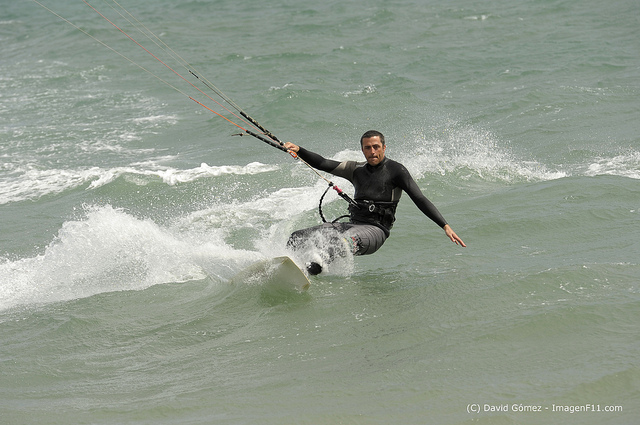<image>What sport is this? It is ambiguous which sport this is. The possibilities could include water skiing, windsurfing, parasailing, water kiting, kitesurfing, or parasurfing. What sport is this? I don't know what sport this is. It can be water skiing, windsurfing, parasailing, water kiting, kitesurfing, or surfing. 